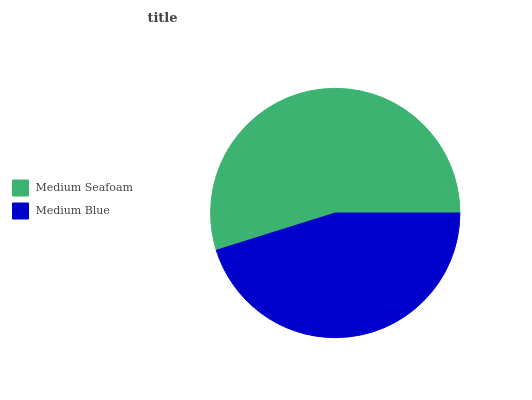Is Medium Blue the minimum?
Answer yes or no. Yes. Is Medium Seafoam the maximum?
Answer yes or no. Yes. Is Medium Blue the maximum?
Answer yes or no. No. Is Medium Seafoam greater than Medium Blue?
Answer yes or no. Yes. Is Medium Blue less than Medium Seafoam?
Answer yes or no. Yes. Is Medium Blue greater than Medium Seafoam?
Answer yes or no. No. Is Medium Seafoam less than Medium Blue?
Answer yes or no. No. Is Medium Seafoam the high median?
Answer yes or no. Yes. Is Medium Blue the low median?
Answer yes or no. Yes. Is Medium Blue the high median?
Answer yes or no. No. Is Medium Seafoam the low median?
Answer yes or no. No. 